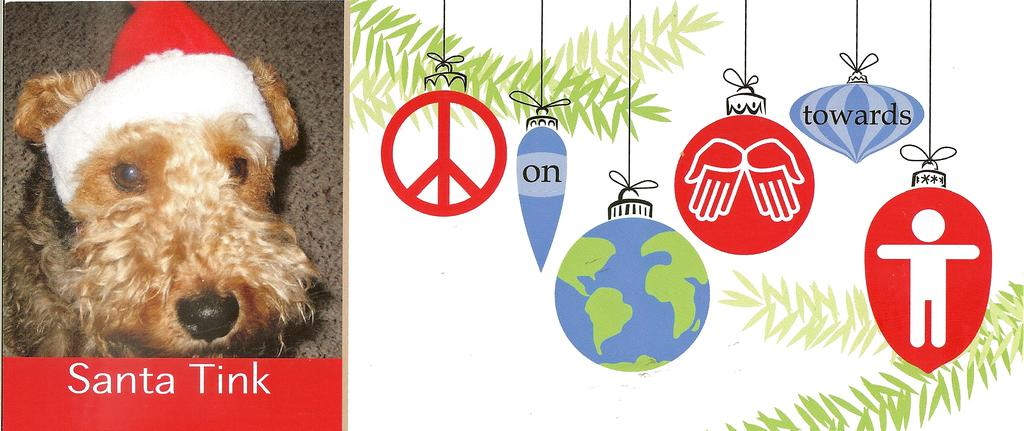What type of image is being depicted in the picture? The image resembles a Christmas greeting card. What can be seen hanging on the right side of the image? There are different shapes and symbols hanging on the right side of the image. What animal is present on the left side of the image? There is a dog on the left side of the image. How is the dog dressed in the image? The dog is wearing a Santa Claus cap. What type of pencil is the dog using to draw in the image? There is no pencil present in the image, and the dog is not shown drawing anything. 